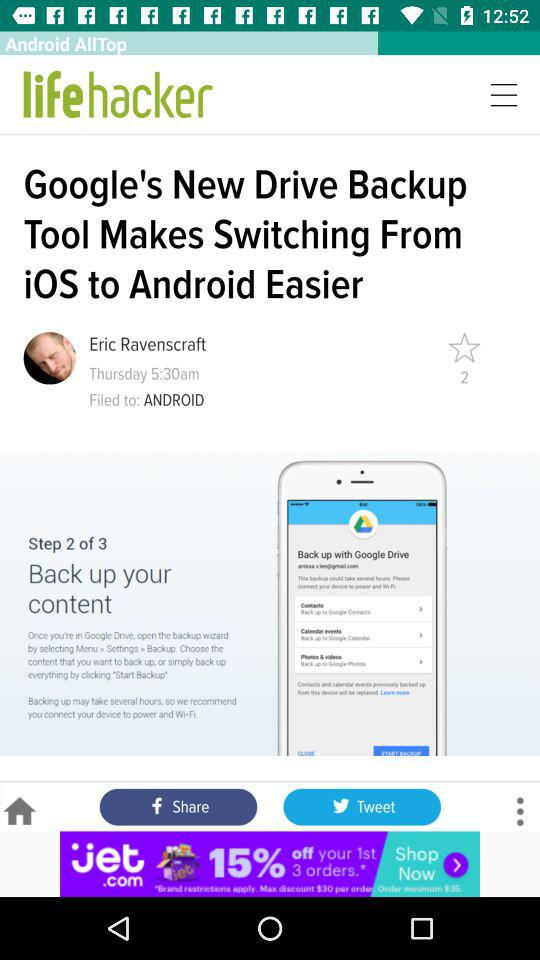What is the day and time? The day is Thursday and the time is 5:30 a.m. 